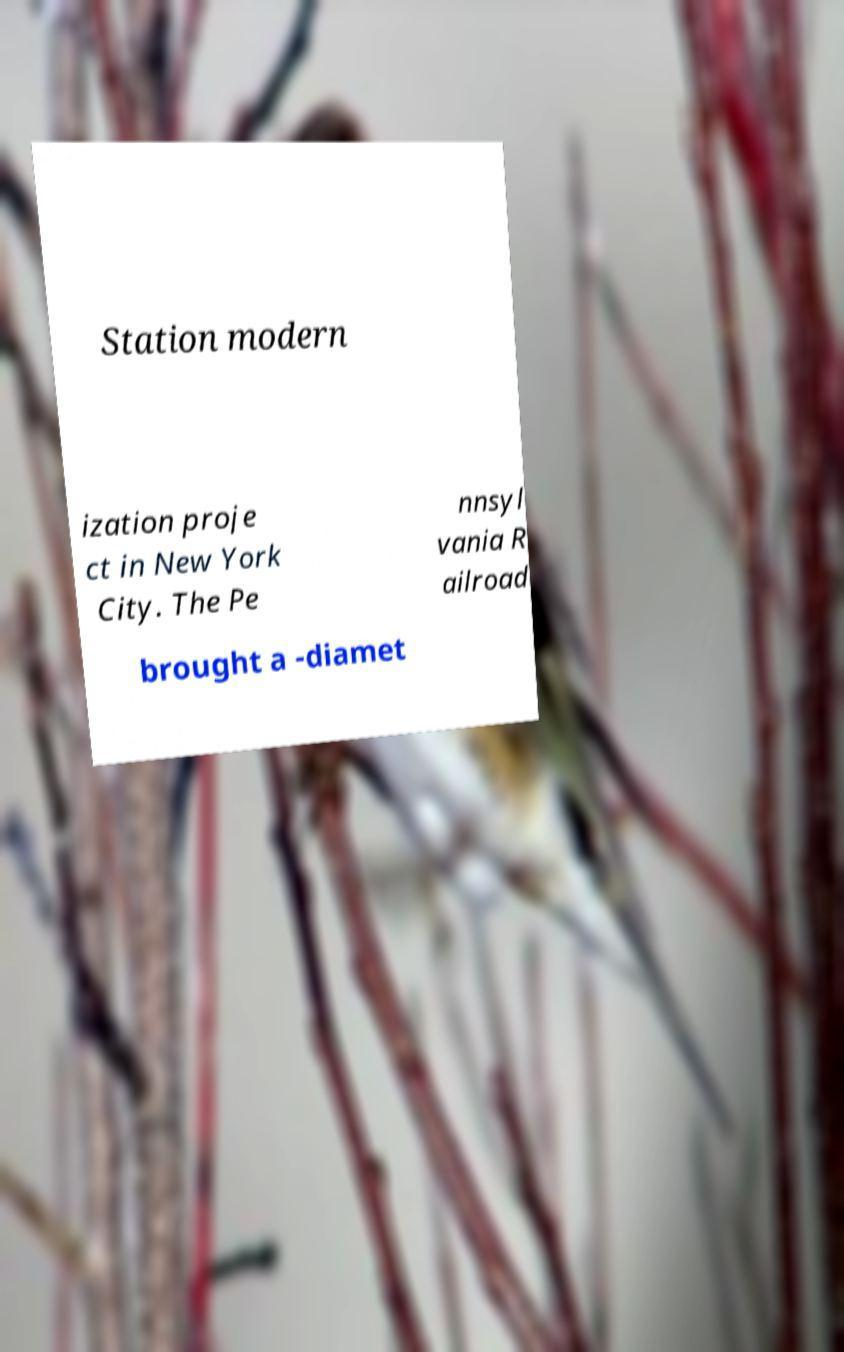Could you assist in decoding the text presented in this image and type it out clearly? Station modern ization proje ct in New York City. The Pe nnsyl vania R ailroad brought a -diamet 